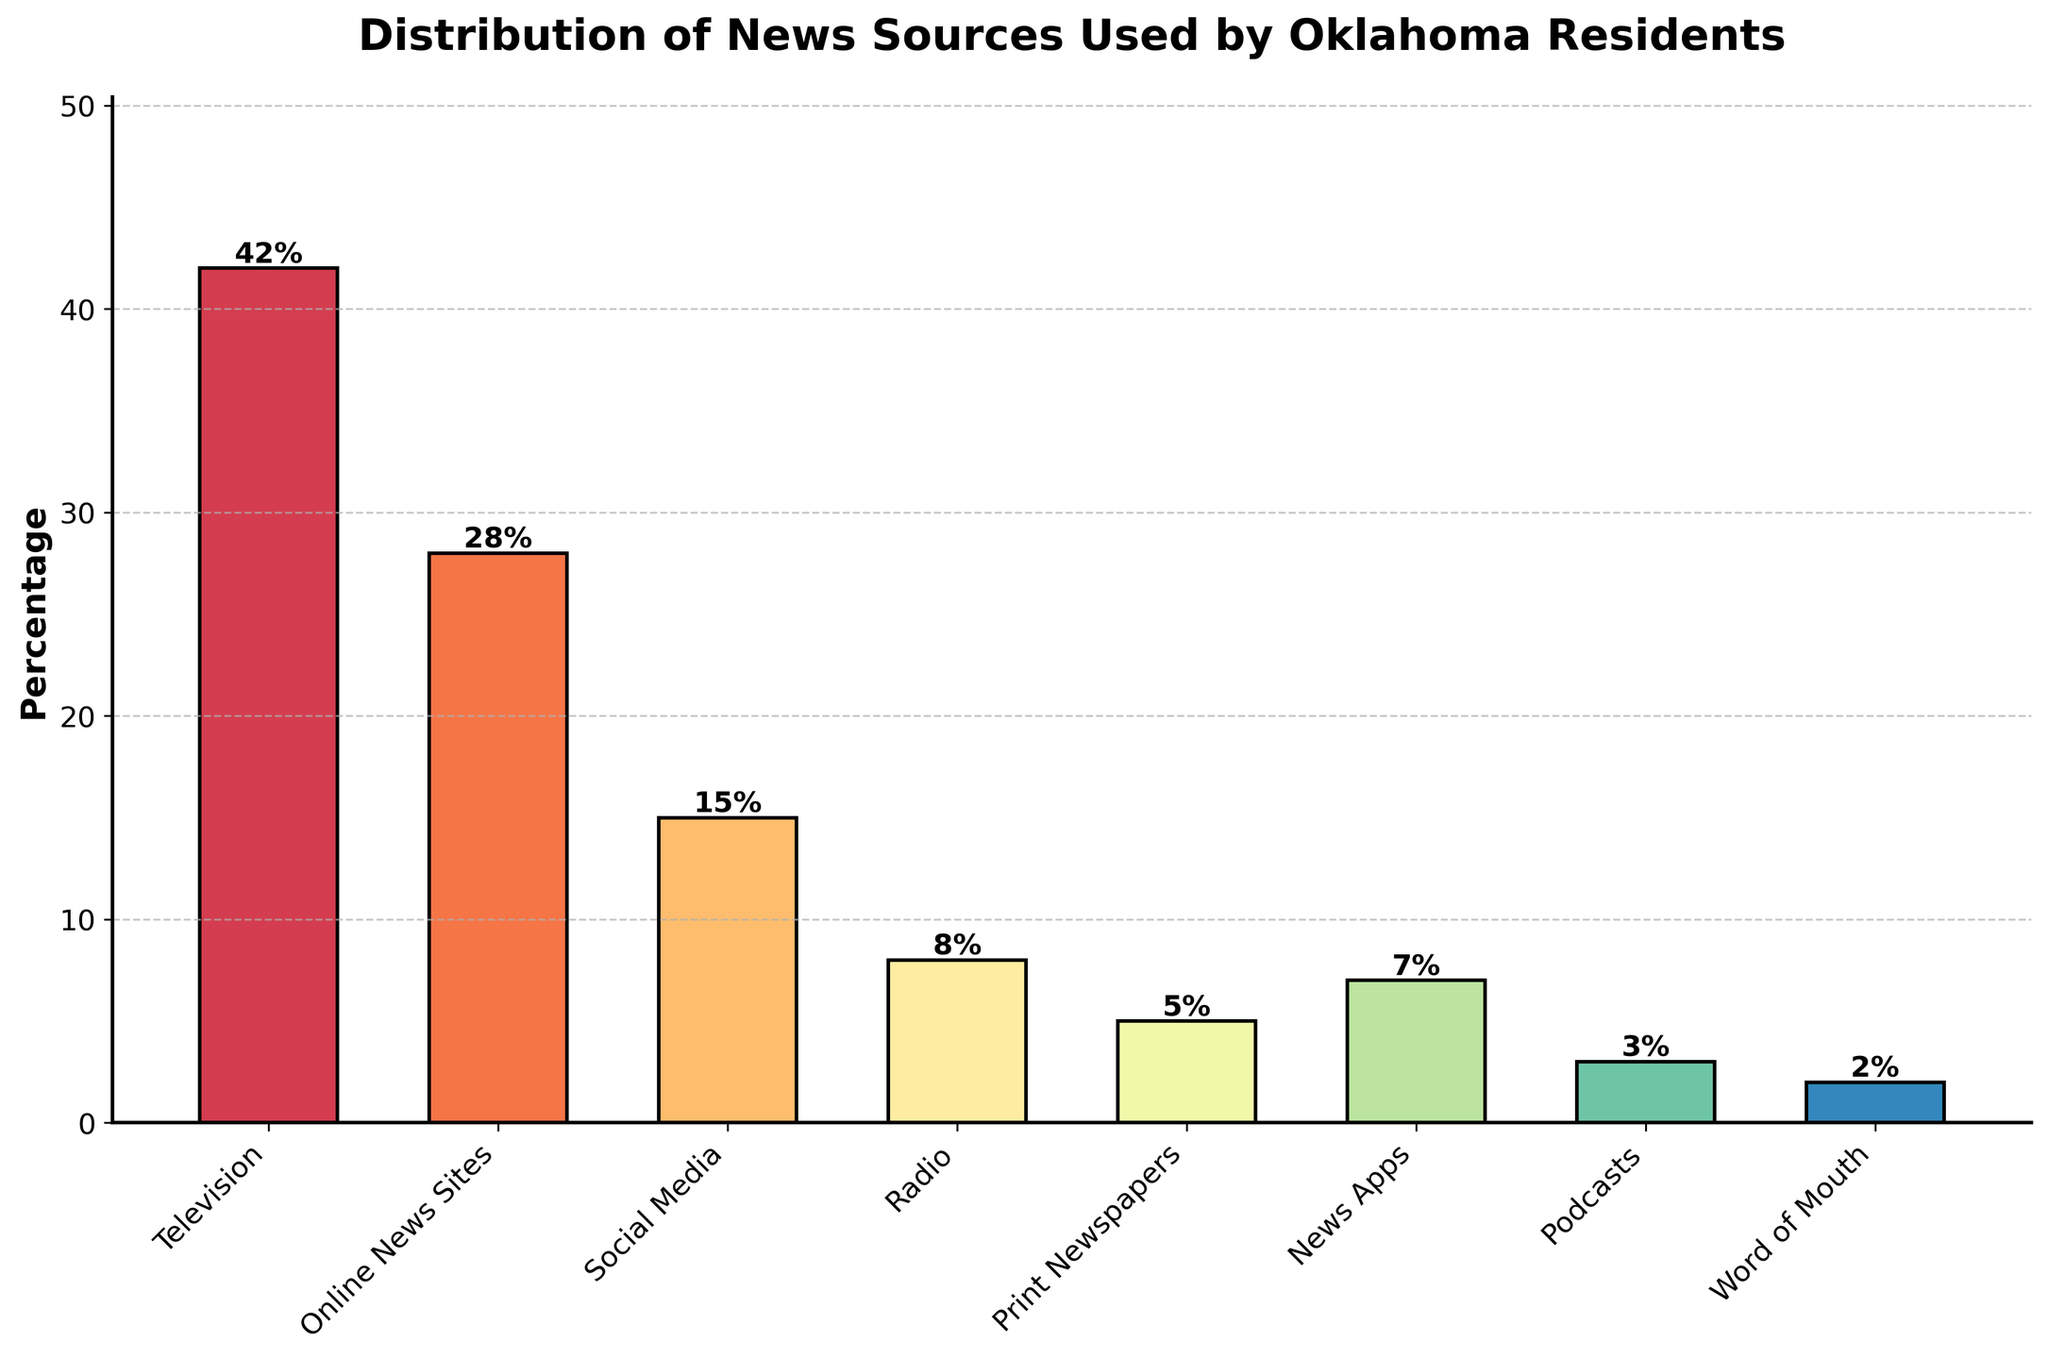What's the percentage of people who use Television as their news source? The figure shows a bar representing Television at a percentage height of 42%.
Answer: 42% Which news source is more popular, Online News Sites or Social Media? The bar for Online News Sites has a percentage of 28%, while Social Media has a percentage of 15%.
Answer: Online News Sites What is the combined percentage of news sources that are online-based (Online News Sites, Social Media, News Apps, and Podcasts)? Online News Sites is 28%, Social Media is 15%, News Apps is 7%, and Podcasts is 3%. Adding these together: 28% + 15% + 7% + 3% = 53%.
Answer: 53% Which news source has the lowest percentage of use among Oklahoma residents? The bar for Word of Mouth is the shortest, showing a percentage of 2%.
Answer: Word of Mouth By how much does the percentage of people using Television as their news source exceed the percentage of people using Print Newspapers? The percentage for Television is 42%, and for Print Newspapers, it is 5%. Subtracting these: 42% - 5% = 37%.
Answer: 37% What's the difference in percentage between those who use Online News Sites and those who use Radio? Online News Sites have a percentage of 28%, while Radio has a percentage of 8%. Subtracting these: 28% - 8% = 20%.
Answer: 20% Which three news sources are the least popular? The three shortest bars are Word of Mouth (2%), Podcasts (3%), and Print Newspapers (5%).
Answer: Word of Mouth, Podcasts, Print Newspapers What is the percentage range of the news sources used by Oklahoma residents? The highest percentage is for Television (42%), and the lowest is for Word of Mouth (2%). The range is calculated as 42% - 2% = 40%.
Answer: 40% How does the percentage of people using News Apps compare to those using Print Newspapers? The percentage for News Apps is 7%, and for Print Newspapers, it is 5%. The percentage for News Apps is thus greater by 2%.
Answer: News Apps is greater by 2% 